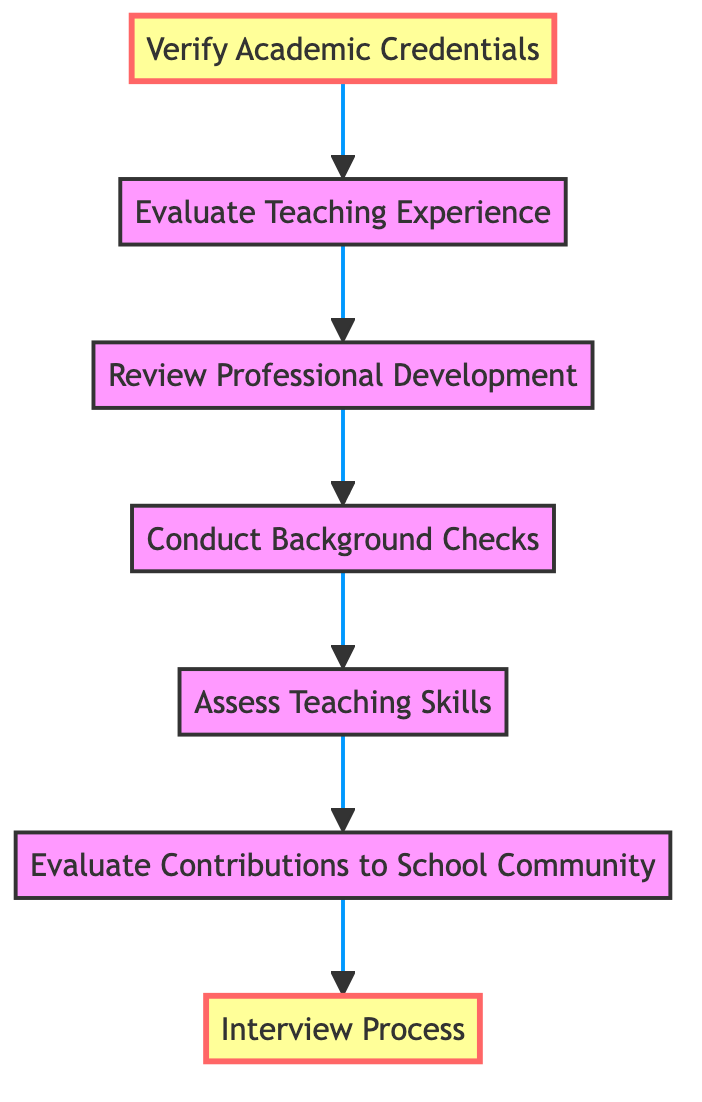What is the first step in evaluating teacher qualifications? The diagram indicates that the first step is "Interview Process", which is the top node in the flow.
Answer: Interview Process How many steps are there in the evaluation process? Counting the nodes from the bottom to the top, there are six distinct steps leading to the "Interview Process".
Answer: Six What comes immediately after verifying academic credentials? Following the "Verify Academic Credentials" node, the diagram shows that the next step is "Evaluate Teaching Experience".
Answer: Evaluate Teaching Experience What is the last step in the flow chart? The final node in the diagram indicates that "Interview Process" is the last step to be conducted.
Answer: Interview Process What type of checks are performed before assessing teaching skills? According to the flow, "Conduct Background Checks" is performed immediately before the "Assess Teaching Skills" step.
Answer: Conduct Background Checks Which step directly evaluates contributions to the school community? The node labeled "Evaluate Contributions to School Community" directly addresses the contributions to the school community after assessing teaching skills.
Answer: Evaluate Contributions to School Community How does evaluating teaching experience relate to academic credentials? The flow chart shows that "Evaluate Teaching Experience" follows directly after "Verify Academic Credentials," indicating a sequence where academic credentials lead to evaluating teaching experience.
Answer: Evaluate Teaching Experience What is the connection between reviewing professional development and conducting background checks? The diagram illustrates that "Review Professional Development" follows "Evaluate Teaching Experience", and "Conduct Background Checks" comes before "Assess Teaching Skills," showing no direct connection between the two; they are separate steps in the process.
Answer: None Which two steps are highlighted in this flow chart? The diagram highlights "Interview Process" and "Verify Academic Credentials", indicating their importance in the overall evaluation.
Answer: Interview Process, Verify Academic Credentials 